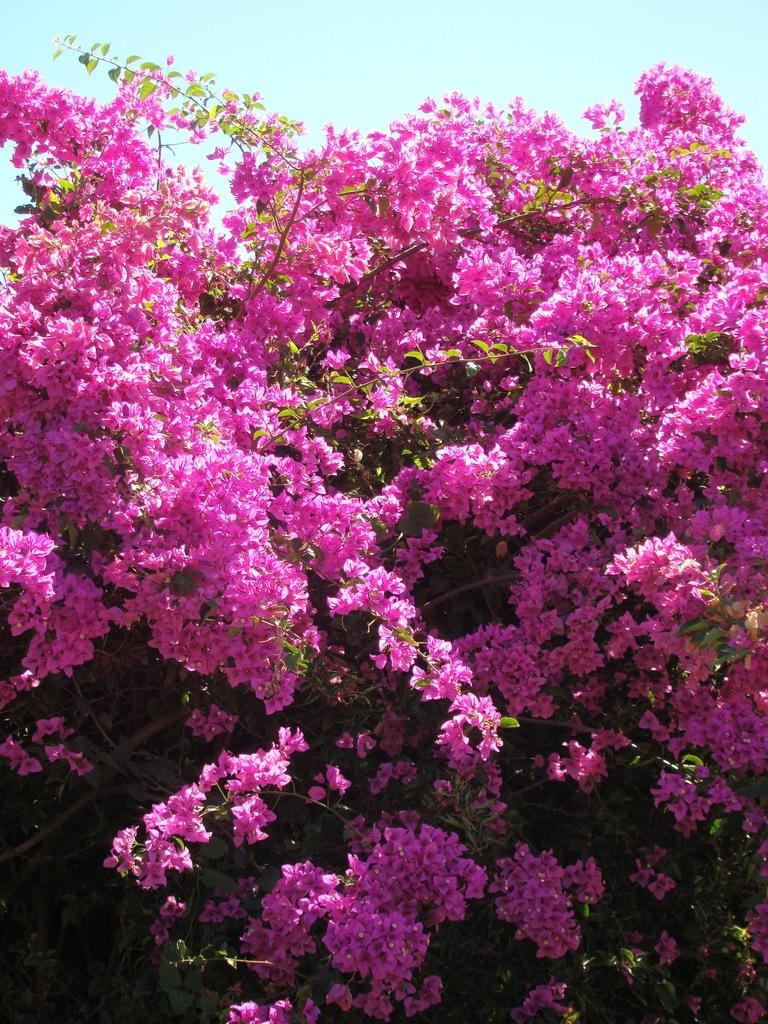What is the main subject of the image? The main subject of the image is a tree. What can be observed about the tree's appearance? The tree has pink color flowers. What else can be seen in the image besides the tree? The sky is visible in the image. What type of smile can be seen on the tree's face in the image? There is no face or smile present on the tree in the image, as trees do not have faces or the ability to smile. 